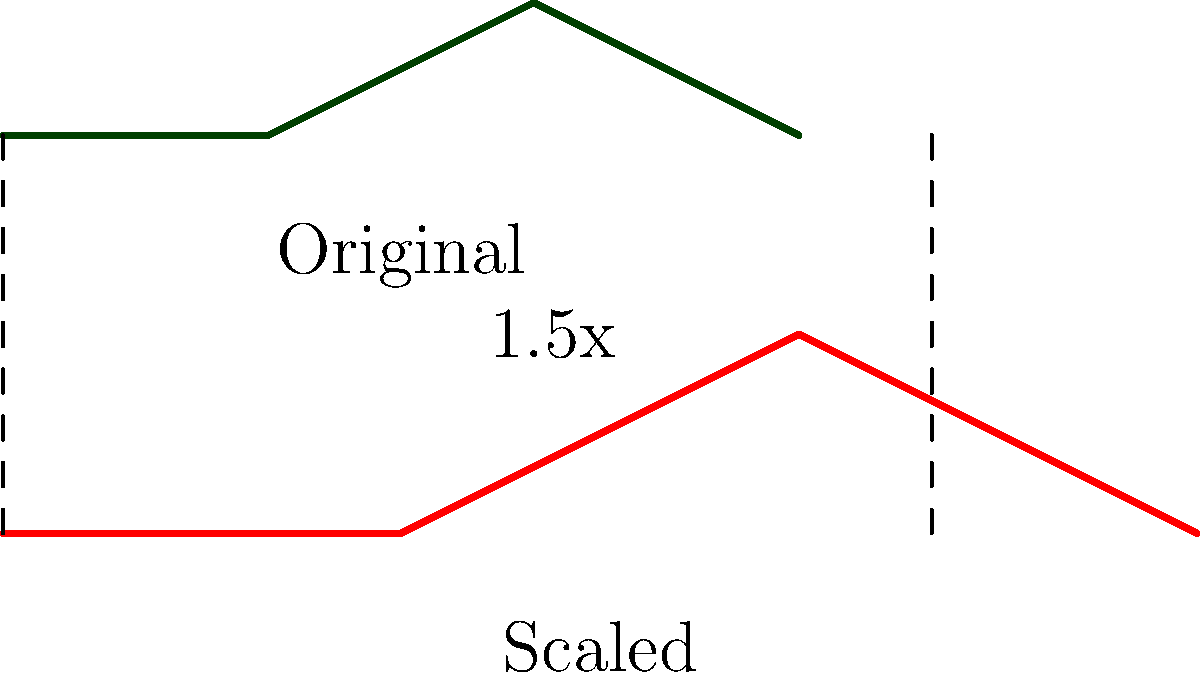A wind turbine blade is scaled up by a factor of 1.5 to increase energy output. If the original blade had a surface area of 120 m², what is the surface area of the scaled-up blade? How does this scaling affect the blade's efficiency? To solve this problem, we'll follow these steps:

1. Understand the scaling factor:
   The blade is scaled up by a factor of 1.5.

2. Calculate the new surface area:
   When a two-dimensional shape is scaled by a factor $k$, its area is multiplied by $k^2$.
   In this case, $k = 1.5$
   New area = Original area × $k^2$
   New area = 120 m² × $(1.5)^2$
   New area = 120 m² × 2.25
   New area = 270 m²

3. Efficiency considerations:
   While scaling up increases the energy output due to a larger swept area, it also affects efficiency:
   
   a) Increased material stress: Larger blades experience greater centrifugal and gravitational forces, requiring stronger, potentially heavier materials.
   
   b) Reynolds number effects: The change in blade size alters the Reynolds number, which can affect the aerodynamic performance.
   
   c) Tip speed: Larger blades have higher tip speeds, which can lead to increased noise and potential bird strikes.
   
   d) Power curve: The relationship between wind speed and power output changes, potentially requiring adjustments to the turbine's operational parameters.

   e) Structural considerations: Larger blades require stronger support structures and foundations, increasing overall costs.

To maintain or improve efficiency, engineers must carefully optimize the blade design, considering factors such as airfoil shape, material selection, and control systems to match the new scale.
Answer: 270 m²; Efficiency affected by material stress, Reynolds number, tip speed, power curve, and structural requirements. 